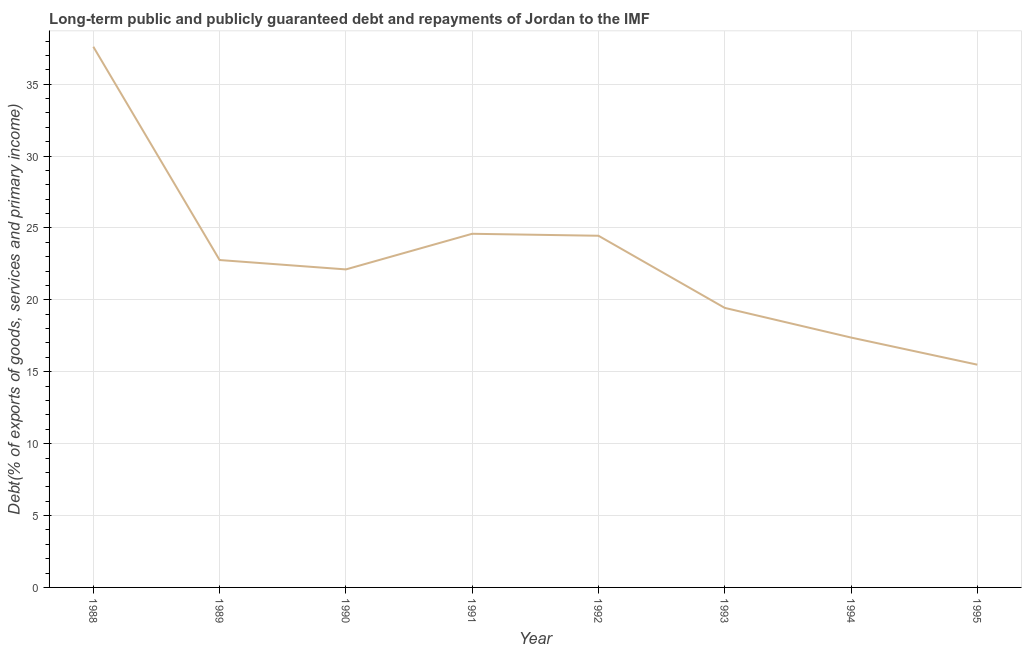What is the debt service in 1988?
Provide a short and direct response. 37.6. Across all years, what is the maximum debt service?
Offer a terse response. 37.6. Across all years, what is the minimum debt service?
Provide a succinct answer. 15.49. In which year was the debt service maximum?
Offer a terse response. 1988. In which year was the debt service minimum?
Ensure brevity in your answer.  1995. What is the sum of the debt service?
Give a very brief answer. 183.85. What is the difference between the debt service in 1990 and 1994?
Ensure brevity in your answer.  4.74. What is the average debt service per year?
Give a very brief answer. 22.98. What is the median debt service?
Keep it short and to the point. 22.44. In how many years, is the debt service greater than 19 %?
Ensure brevity in your answer.  6. Do a majority of the years between 1995 and 1989 (inclusive) have debt service greater than 2 %?
Provide a succinct answer. Yes. What is the ratio of the debt service in 1990 to that in 1995?
Your answer should be very brief. 1.43. Is the debt service in 1988 less than that in 1989?
Offer a very short reply. No. Is the difference between the debt service in 1991 and 1993 greater than the difference between any two years?
Your answer should be very brief. No. What is the difference between the highest and the second highest debt service?
Offer a terse response. 13.01. Is the sum of the debt service in 1989 and 1995 greater than the maximum debt service across all years?
Provide a short and direct response. Yes. What is the difference between the highest and the lowest debt service?
Provide a short and direct response. 22.11. In how many years, is the debt service greater than the average debt service taken over all years?
Give a very brief answer. 3. Does the debt service monotonically increase over the years?
Provide a short and direct response. No. How many lines are there?
Your answer should be compact. 1. What is the title of the graph?
Offer a terse response. Long-term public and publicly guaranteed debt and repayments of Jordan to the IMF. What is the label or title of the Y-axis?
Provide a succinct answer. Debt(% of exports of goods, services and primary income). What is the Debt(% of exports of goods, services and primary income) in 1988?
Provide a succinct answer. 37.6. What is the Debt(% of exports of goods, services and primary income) of 1989?
Give a very brief answer. 22.77. What is the Debt(% of exports of goods, services and primary income) of 1990?
Offer a very short reply. 22.12. What is the Debt(% of exports of goods, services and primary income) of 1991?
Offer a terse response. 24.59. What is the Debt(% of exports of goods, services and primary income) in 1992?
Your answer should be very brief. 24.46. What is the Debt(% of exports of goods, services and primary income) in 1993?
Your response must be concise. 19.44. What is the Debt(% of exports of goods, services and primary income) of 1994?
Your answer should be very brief. 17.38. What is the Debt(% of exports of goods, services and primary income) in 1995?
Make the answer very short. 15.49. What is the difference between the Debt(% of exports of goods, services and primary income) in 1988 and 1989?
Offer a terse response. 14.83. What is the difference between the Debt(% of exports of goods, services and primary income) in 1988 and 1990?
Your answer should be compact. 15.49. What is the difference between the Debt(% of exports of goods, services and primary income) in 1988 and 1991?
Your answer should be very brief. 13.01. What is the difference between the Debt(% of exports of goods, services and primary income) in 1988 and 1992?
Your answer should be compact. 13.15. What is the difference between the Debt(% of exports of goods, services and primary income) in 1988 and 1993?
Offer a terse response. 18.16. What is the difference between the Debt(% of exports of goods, services and primary income) in 1988 and 1994?
Keep it short and to the point. 20.22. What is the difference between the Debt(% of exports of goods, services and primary income) in 1988 and 1995?
Your answer should be compact. 22.11. What is the difference between the Debt(% of exports of goods, services and primary income) in 1989 and 1990?
Make the answer very short. 0.65. What is the difference between the Debt(% of exports of goods, services and primary income) in 1989 and 1991?
Provide a succinct answer. -1.83. What is the difference between the Debt(% of exports of goods, services and primary income) in 1989 and 1992?
Provide a succinct answer. -1.69. What is the difference between the Debt(% of exports of goods, services and primary income) in 1989 and 1993?
Make the answer very short. 3.33. What is the difference between the Debt(% of exports of goods, services and primary income) in 1989 and 1994?
Ensure brevity in your answer.  5.39. What is the difference between the Debt(% of exports of goods, services and primary income) in 1989 and 1995?
Your answer should be compact. 7.28. What is the difference between the Debt(% of exports of goods, services and primary income) in 1990 and 1991?
Your answer should be compact. -2.48. What is the difference between the Debt(% of exports of goods, services and primary income) in 1990 and 1992?
Give a very brief answer. -2.34. What is the difference between the Debt(% of exports of goods, services and primary income) in 1990 and 1993?
Your response must be concise. 2.68. What is the difference between the Debt(% of exports of goods, services and primary income) in 1990 and 1994?
Offer a terse response. 4.74. What is the difference between the Debt(% of exports of goods, services and primary income) in 1990 and 1995?
Make the answer very short. 6.63. What is the difference between the Debt(% of exports of goods, services and primary income) in 1991 and 1992?
Offer a very short reply. 0.14. What is the difference between the Debt(% of exports of goods, services and primary income) in 1991 and 1993?
Provide a succinct answer. 5.15. What is the difference between the Debt(% of exports of goods, services and primary income) in 1991 and 1994?
Give a very brief answer. 7.22. What is the difference between the Debt(% of exports of goods, services and primary income) in 1991 and 1995?
Keep it short and to the point. 9.1. What is the difference between the Debt(% of exports of goods, services and primary income) in 1992 and 1993?
Keep it short and to the point. 5.02. What is the difference between the Debt(% of exports of goods, services and primary income) in 1992 and 1994?
Offer a terse response. 7.08. What is the difference between the Debt(% of exports of goods, services and primary income) in 1992 and 1995?
Your answer should be compact. 8.97. What is the difference between the Debt(% of exports of goods, services and primary income) in 1993 and 1994?
Offer a very short reply. 2.06. What is the difference between the Debt(% of exports of goods, services and primary income) in 1993 and 1995?
Make the answer very short. 3.95. What is the difference between the Debt(% of exports of goods, services and primary income) in 1994 and 1995?
Make the answer very short. 1.89. What is the ratio of the Debt(% of exports of goods, services and primary income) in 1988 to that in 1989?
Give a very brief answer. 1.65. What is the ratio of the Debt(% of exports of goods, services and primary income) in 1988 to that in 1990?
Ensure brevity in your answer.  1.7. What is the ratio of the Debt(% of exports of goods, services and primary income) in 1988 to that in 1991?
Your answer should be compact. 1.53. What is the ratio of the Debt(% of exports of goods, services and primary income) in 1988 to that in 1992?
Keep it short and to the point. 1.54. What is the ratio of the Debt(% of exports of goods, services and primary income) in 1988 to that in 1993?
Offer a terse response. 1.93. What is the ratio of the Debt(% of exports of goods, services and primary income) in 1988 to that in 1994?
Offer a terse response. 2.16. What is the ratio of the Debt(% of exports of goods, services and primary income) in 1988 to that in 1995?
Offer a terse response. 2.43. What is the ratio of the Debt(% of exports of goods, services and primary income) in 1989 to that in 1991?
Keep it short and to the point. 0.93. What is the ratio of the Debt(% of exports of goods, services and primary income) in 1989 to that in 1992?
Keep it short and to the point. 0.93. What is the ratio of the Debt(% of exports of goods, services and primary income) in 1989 to that in 1993?
Make the answer very short. 1.17. What is the ratio of the Debt(% of exports of goods, services and primary income) in 1989 to that in 1994?
Give a very brief answer. 1.31. What is the ratio of the Debt(% of exports of goods, services and primary income) in 1989 to that in 1995?
Your answer should be compact. 1.47. What is the ratio of the Debt(% of exports of goods, services and primary income) in 1990 to that in 1991?
Offer a terse response. 0.9. What is the ratio of the Debt(% of exports of goods, services and primary income) in 1990 to that in 1992?
Your answer should be compact. 0.9. What is the ratio of the Debt(% of exports of goods, services and primary income) in 1990 to that in 1993?
Your response must be concise. 1.14. What is the ratio of the Debt(% of exports of goods, services and primary income) in 1990 to that in 1994?
Offer a terse response. 1.27. What is the ratio of the Debt(% of exports of goods, services and primary income) in 1990 to that in 1995?
Provide a short and direct response. 1.43. What is the ratio of the Debt(% of exports of goods, services and primary income) in 1991 to that in 1993?
Ensure brevity in your answer.  1.26. What is the ratio of the Debt(% of exports of goods, services and primary income) in 1991 to that in 1994?
Your answer should be very brief. 1.42. What is the ratio of the Debt(% of exports of goods, services and primary income) in 1991 to that in 1995?
Give a very brief answer. 1.59. What is the ratio of the Debt(% of exports of goods, services and primary income) in 1992 to that in 1993?
Give a very brief answer. 1.26. What is the ratio of the Debt(% of exports of goods, services and primary income) in 1992 to that in 1994?
Provide a succinct answer. 1.41. What is the ratio of the Debt(% of exports of goods, services and primary income) in 1992 to that in 1995?
Give a very brief answer. 1.58. What is the ratio of the Debt(% of exports of goods, services and primary income) in 1993 to that in 1994?
Your answer should be compact. 1.12. What is the ratio of the Debt(% of exports of goods, services and primary income) in 1993 to that in 1995?
Offer a very short reply. 1.25. What is the ratio of the Debt(% of exports of goods, services and primary income) in 1994 to that in 1995?
Your response must be concise. 1.12. 